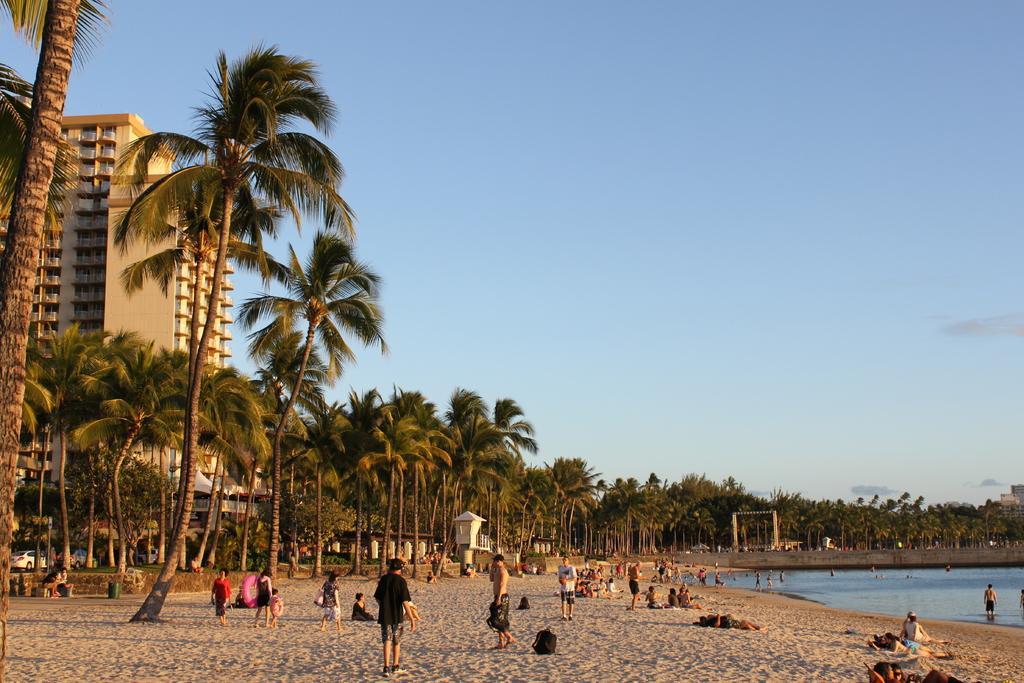Please provide a concise description of this image. In this image I can see number of people where few are sitting on the ground and rest all are standing. I can also see number of trees in the front and in the background. On the right side I can see water and on the left side I can see a building and few vehicles. In the background I can see clouds and the sky. I can also see few stuffs on the ground. 